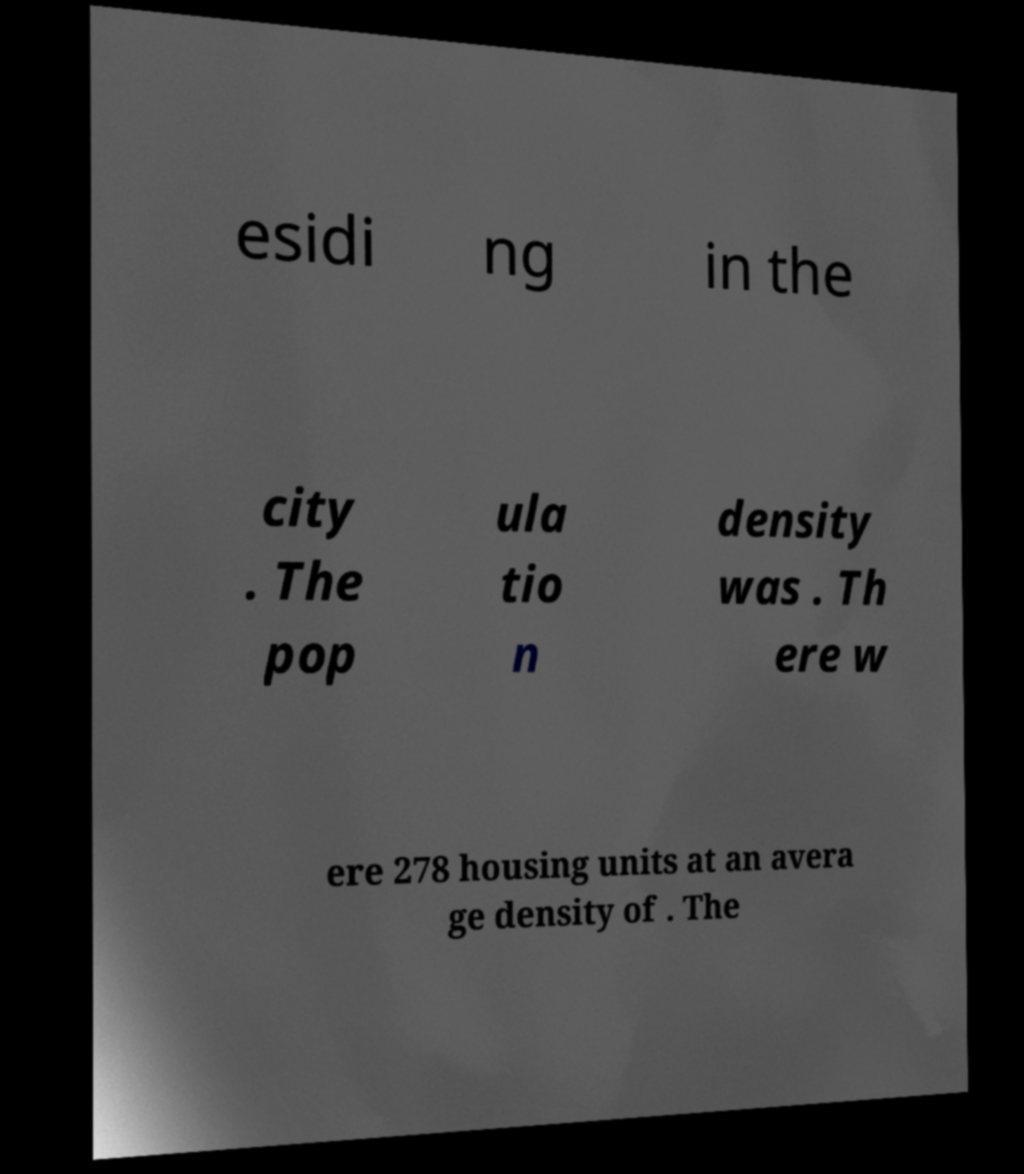I need the written content from this picture converted into text. Can you do that? esidi ng in the city . The pop ula tio n density was . Th ere w ere 278 housing units at an avera ge density of . The 